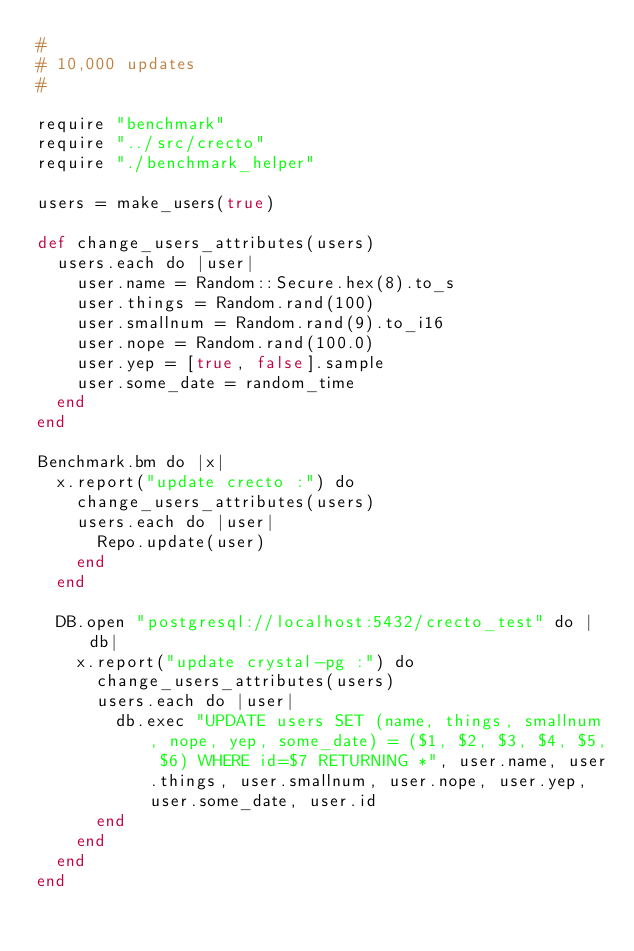<code> <loc_0><loc_0><loc_500><loc_500><_Crystal_>#
# 10,000 updates
#

require "benchmark"
require "../src/crecto"
require "./benchmark_helper"

users = make_users(true)

def change_users_attributes(users)
  users.each do |user|
    user.name = Random::Secure.hex(8).to_s
    user.things = Random.rand(100)
    user.smallnum = Random.rand(9).to_i16
    user.nope = Random.rand(100.0)
    user.yep = [true, false].sample
    user.some_date = random_time
  end
end

Benchmark.bm do |x|
  x.report("update crecto :") do
    change_users_attributes(users)
    users.each do |user|
      Repo.update(user)
    end
  end

  DB.open "postgresql://localhost:5432/crecto_test" do |db|
    x.report("update crystal-pg :") do
      change_users_attributes(users)
      users.each do |user|
        db.exec "UPDATE users SET (name, things, smallnum, nope, yep, some_date) = ($1, $2, $3, $4, $5, $6) WHERE id=$7 RETURNING *", user.name, user.things, user.smallnum, user.nope, user.yep, user.some_date, user.id
      end
    end
  end
end
</code> 